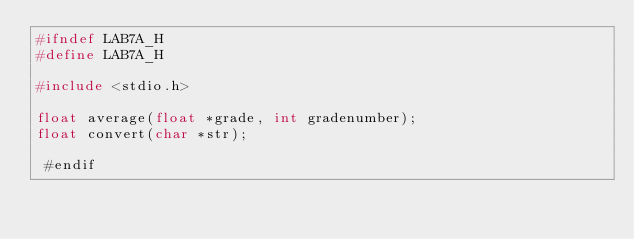Convert code to text. <code><loc_0><loc_0><loc_500><loc_500><_C_>#ifndef LAB7A_H
#define LAB7A_H

#include <stdio.h>

float average(float *grade, int gradenumber);
float convert(char *str);

 #endif
</code> 